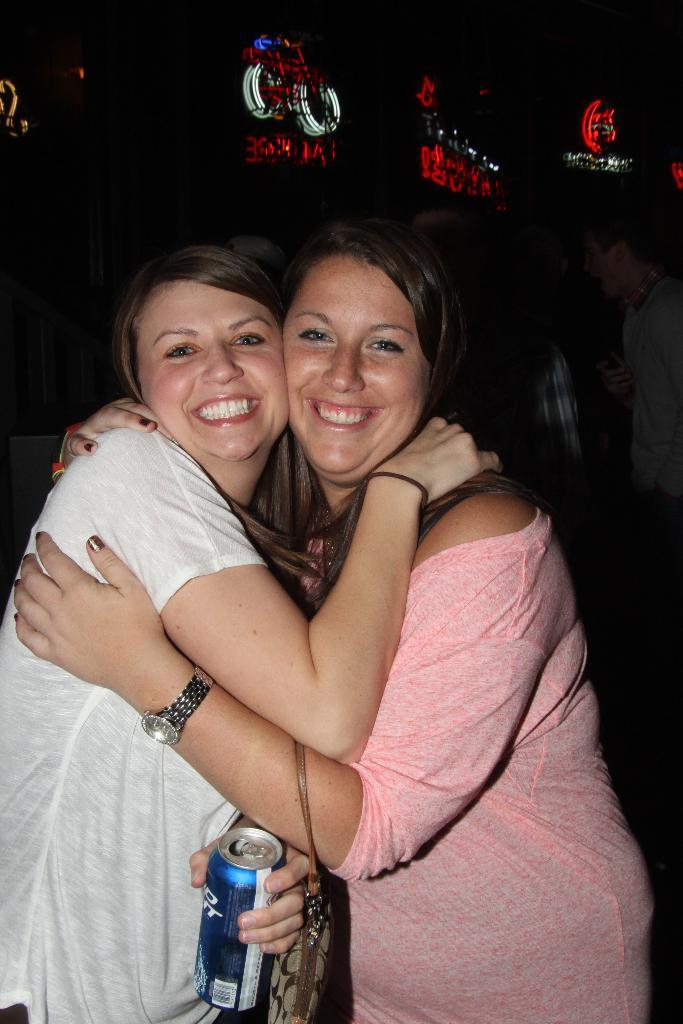How many people are in the image? There are two persons in the image. What are the two persons doing? The two persons are hugging and holding a bottle. What can be seen in the background of the image? There are labels and text visible in the background, along with lights associated with them. What type of error can be seen in the image? There is no error present in the image; it features two people hugging and holding a bottle, along with labels, text, and lights in the background. What is the topic of the argument between the two persons in the image? There is no argument present in the image; the two persons are hugging and holding a bottle. 